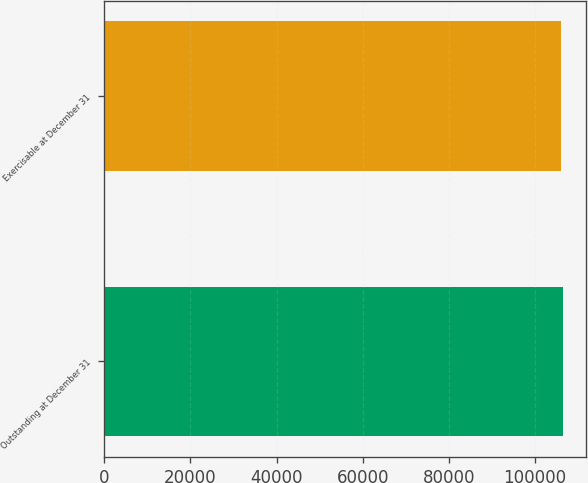<chart> <loc_0><loc_0><loc_500><loc_500><bar_chart><fcel>Outstanding at December 31<fcel>Exercisable at December 31<nl><fcel>106485<fcel>105939<nl></chart> 